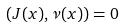Convert formula to latex. <formula><loc_0><loc_0><loc_500><loc_500>( J ( x ) , \nu ( x ) ) = 0</formula> 